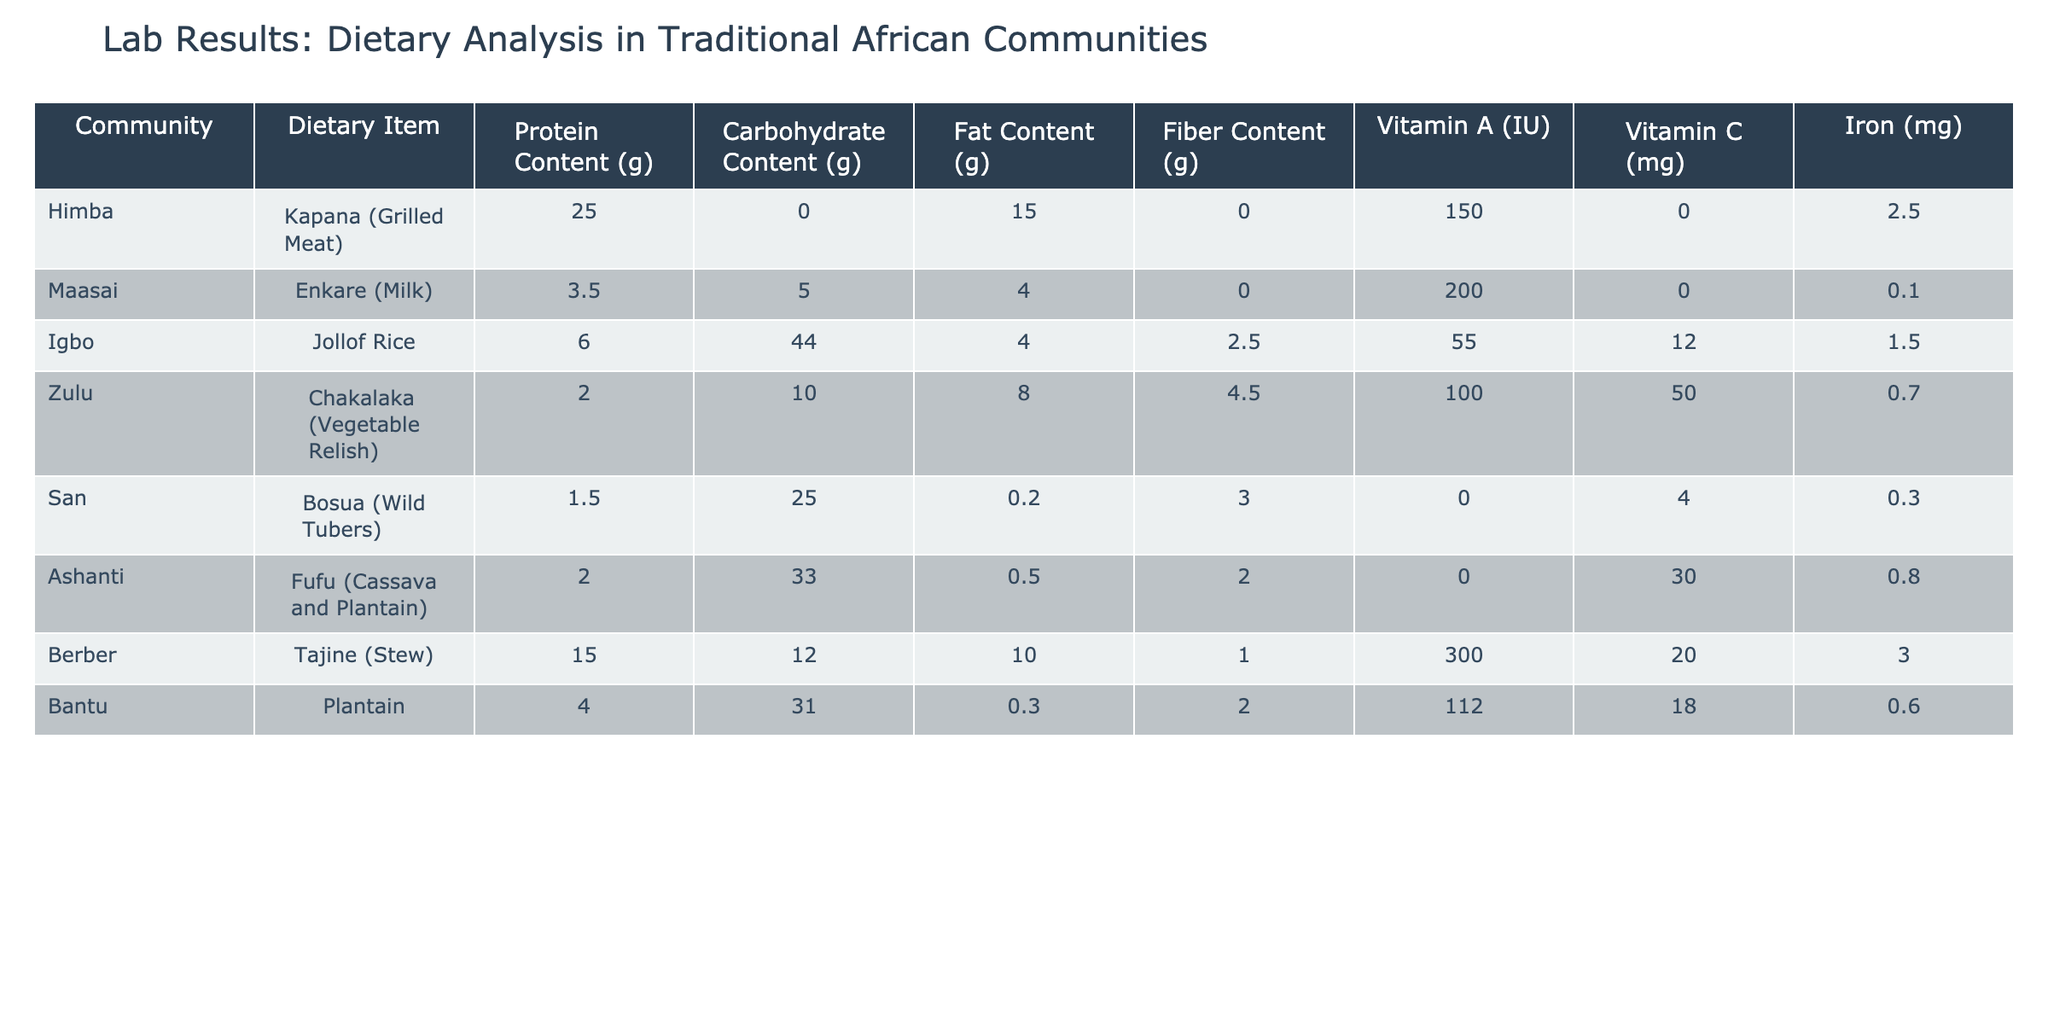What is the protein content in the Himba community’s dietary item, Kapana? The table specifically lists the protein content under the corresponding dietary item for the Himba community. For Kapana, the protein content is directly given as 25.0 grams.
Answer: 25.0 grams Which dietary item has the highest fat content among the communities listed? To find the highest fat content, I will look for the maximum value in the "Fat Content (g)" column. The value of 15.0 grams for Kapana in the Himba community is the highest, compared to other entries.
Answer: Kapana (Grilled Meat) Is the iron content in the Maasai community's Enkare higher than that in the San community's Bosua? The iron content for Maasai's Enkare is 0.1 mg, while for San's Bosua it is 0.3 mg. Since 0.1 is less than 0.3, it confirms that the Maasai's iron content is not higher.
Answer: No What is the average carbohydrate content of all listed diet items? To find the average carbohydrate content, I will sum the carbohydrate values from the table: 0.0 + 5.0 + 44.0 + 10.0 + 25.0 + 33.0 + 12.0 + 31.0 = 156.0 grams. There are 8 diet items, so I will divide the total by 8: 156.0 / 8 = 19.5 grams.
Answer: 19.5 grams Which community’s dietary item has the highest combined content of protein, fat, and fiber? To determine the highest combined content, I will sum the protein, fat, and fiber values for each community:
- Himba: 25.0 + 15.0 + 0.0 = 40.0
- Maasai: 3.5 + 4.0 + 0.0 = 7.5
- Igbo: 6.0 + 4.0 + 2.5 = 12.5
- Zulu: 2.0 + 8.0 + 4.5 = 14.5
- San: 1.5 + 0.2 + 3.0 = 4.7
- Ashanti: 2.0 + 0.5 + 2.0 = 4.5
- Berber: 15.0 + 10.0 + 1.0 = 26.0
- Bantu: 4.0 + 0.3 + 2.0 = 6.3
The highest is 40.0 from the Himba community.
Answer: Himba Does the Zulu community's Chakalaka provide more Vitamin C than the Igbo community's Jollof Rice? For the Zulu community, Chakalaka has Vitamin C content of 50.0 mg, and Igbo's Jollof Rice has 12.0 mg. Since 50.0 is greater than 12.0, it confirms that Chakalaka provides more Vitamin C.
Answer: Yes Which dietary item among the listed ones contributes the least protein? The protein content values for each item are: 25.0, 3.5, 6.0, 2.0, 1.5, 2.0, 15.0, and 4.0 grams. The minimum value is 1.5 grams from San's Bosua, indicating it has the least protein contribution.
Answer: Bosua (Wild Tubers) What is the total fiber content for the Ashanti community diet? The table indicates that the fiber content for Ashanti's Fufu is 2.0 grams. Therefore, the total fiber content for this community is directly given as 2.0 grams.
Answer: 2.0 grams 